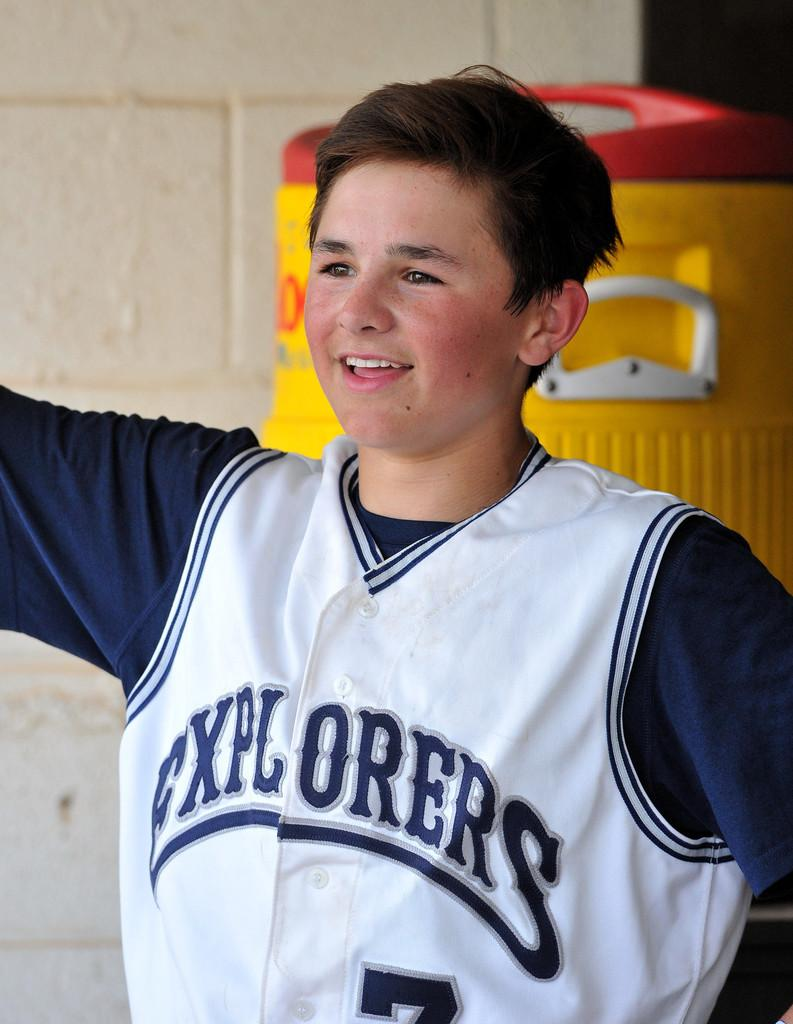<image>
Relay a brief, clear account of the picture shown. A boy in an Explorers jersey stands in front of a big yellow drink cooler. 